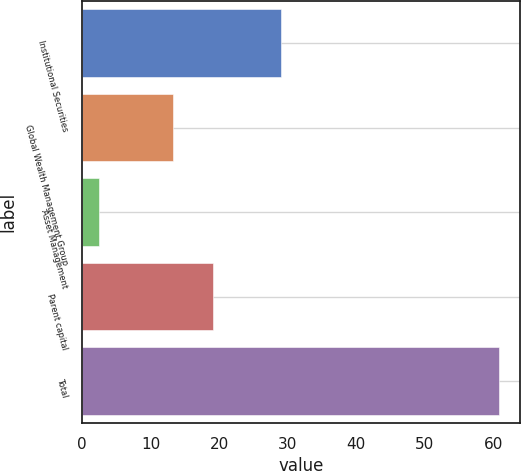Convert chart to OTSL. <chart><loc_0><loc_0><loc_500><loc_500><bar_chart><fcel>Institutional Securities<fcel>Global Wealth Management Group<fcel>Asset Management<fcel>Parent capital<fcel>Total<nl><fcel>29<fcel>13.3<fcel>2.4<fcel>19.14<fcel>60.8<nl></chart> 